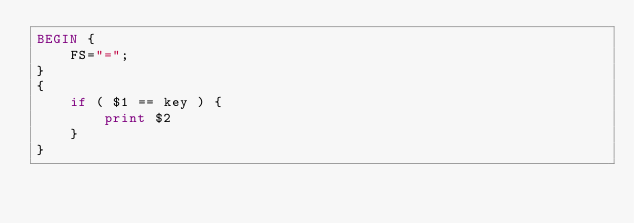Convert code to text. <code><loc_0><loc_0><loc_500><loc_500><_Awk_>BEGIN {
	FS="=";
}
{
	if ( $1 == key ) {
		print $2
	}
}
</code> 